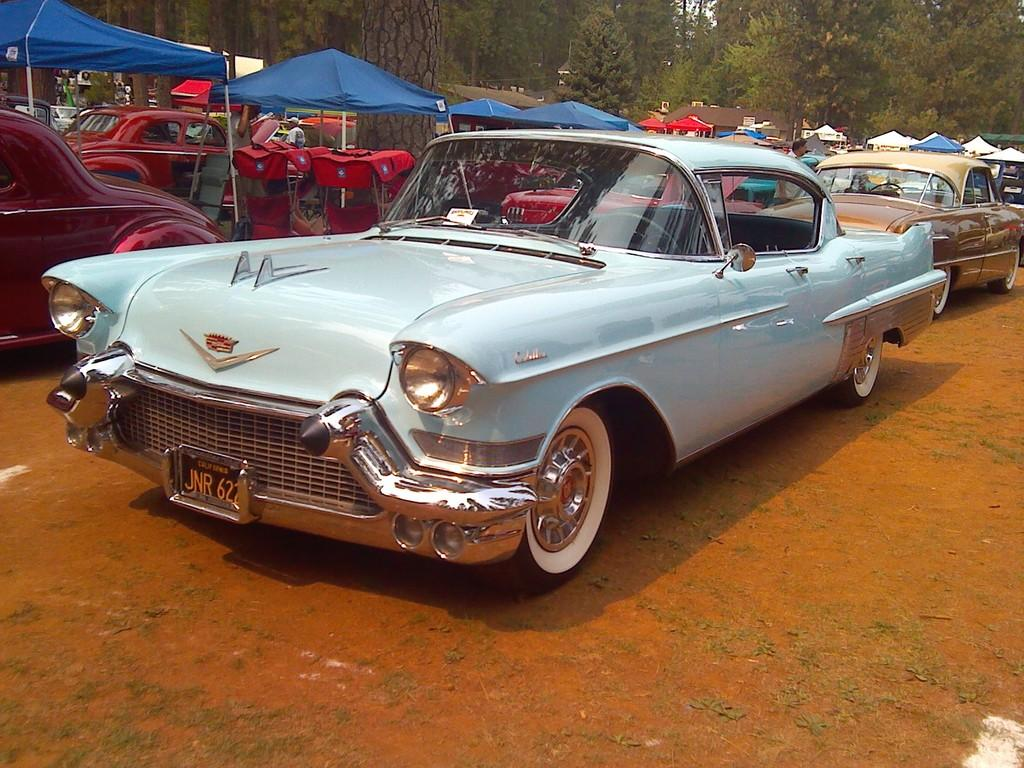What type of vehicles can be seen in the image? There are cars in the image. What structures are present in the image? There are tents in the image. What type of natural elements are visible in the background of the image? There are trees in the background of the image. What is visible at the bottom of the image? The ground is visible at the bottom of the image. How many icicles are hanging from the cars in the image? There are no icicles present in the image; it appears to be outdoors with trees in the background, but no icicles are visible. 